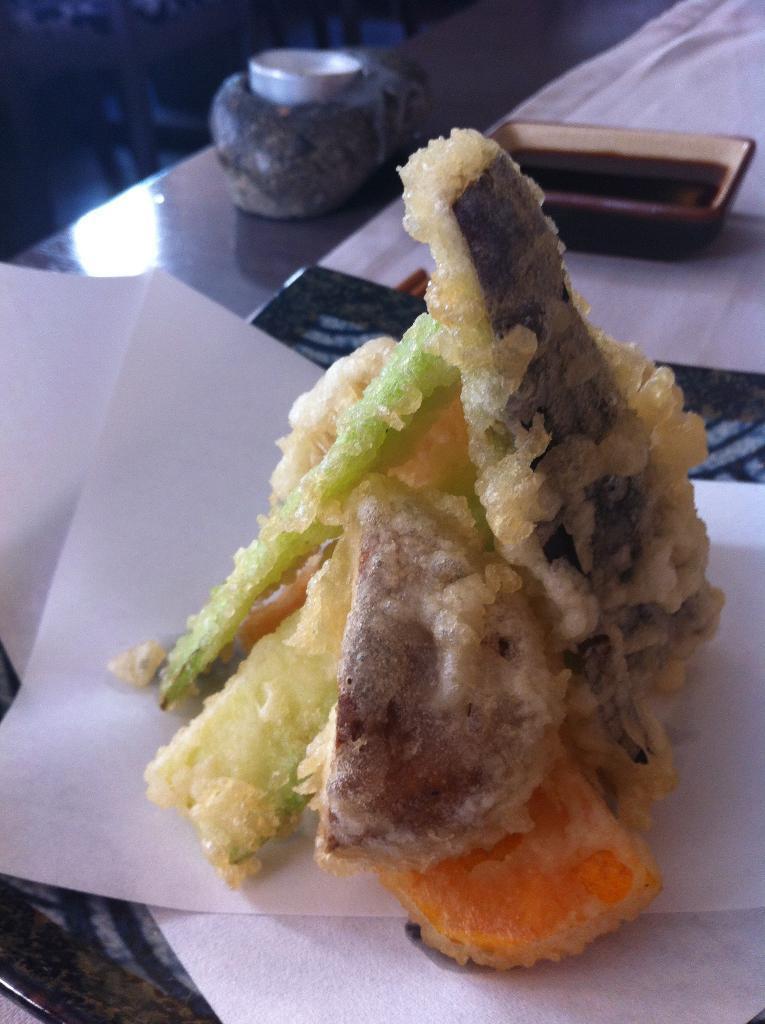In one or two sentences, can you explain what this image depicts? In the center of the image we can see a food item is present in the plate. And also we can see a bowl of ketchup, paper, cloth are present on the table. 